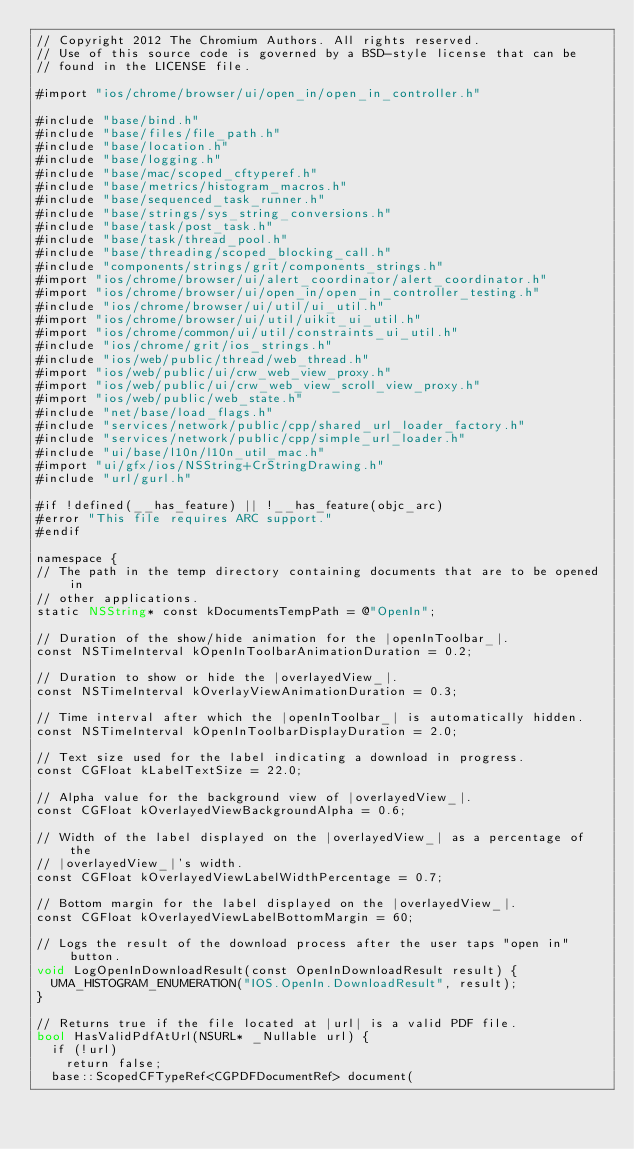Convert code to text. <code><loc_0><loc_0><loc_500><loc_500><_ObjectiveC_>// Copyright 2012 The Chromium Authors. All rights reserved.
// Use of this source code is governed by a BSD-style license that can be
// found in the LICENSE file.

#import "ios/chrome/browser/ui/open_in/open_in_controller.h"

#include "base/bind.h"
#include "base/files/file_path.h"
#include "base/location.h"
#include "base/logging.h"
#include "base/mac/scoped_cftyperef.h"
#include "base/metrics/histogram_macros.h"
#include "base/sequenced_task_runner.h"
#include "base/strings/sys_string_conversions.h"
#include "base/task/post_task.h"
#include "base/task/thread_pool.h"
#include "base/threading/scoped_blocking_call.h"
#include "components/strings/grit/components_strings.h"
#import "ios/chrome/browser/ui/alert_coordinator/alert_coordinator.h"
#import "ios/chrome/browser/ui/open_in/open_in_controller_testing.h"
#include "ios/chrome/browser/ui/util/ui_util.h"
#import "ios/chrome/browser/ui/util/uikit_ui_util.h"
#import "ios/chrome/common/ui/util/constraints_ui_util.h"
#include "ios/chrome/grit/ios_strings.h"
#include "ios/web/public/thread/web_thread.h"
#import "ios/web/public/ui/crw_web_view_proxy.h"
#import "ios/web/public/ui/crw_web_view_scroll_view_proxy.h"
#import "ios/web/public/web_state.h"
#include "net/base/load_flags.h"
#include "services/network/public/cpp/shared_url_loader_factory.h"
#include "services/network/public/cpp/simple_url_loader.h"
#include "ui/base/l10n/l10n_util_mac.h"
#import "ui/gfx/ios/NSString+CrStringDrawing.h"
#include "url/gurl.h"

#if !defined(__has_feature) || !__has_feature(objc_arc)
#error "This file requires ARC support."
#endif

namespace {
// The path in the temp directory containing documents that are to be opened in
// other applications.
static NSString* const kDocumentsTempPath = @"OpenIn";

// Duration of the show/hide animation for the |openInToolbar_|.
const NSTimeInterval kOpenInToolbarAnimationDuration = 0.2;

// Duration to show or hide the |overlayedView_|.
const NSTimeInterval kOverlayViewAnimationDuration = 0.3;

// Time interval after which the |openInToolbar_| is automatically hidden.
const NSTimeInterval kOpenInToolbarDisplayDuration = 2.0;

// Text size used for the label indicating a download in progress.
const CGFloat kLabelTextSize = 22.0;

// Alpha value for the background view of |overlayedView_|.
const CGFloat kOverlayedViewBackgroundAlpha = 0.6;

// Width of the label displayed on the |overlayedView_| as a percentage of the
// |overlayedView_|'s width.
const CGFloat kOverlayedViewLabelWidthPercentage = 0.7;

// Bottom margin for the label displayed on the |overlayedView_|.
const CGFloat kOverlayedViewLabelBottomMargin = 60;

// Logs the result of the download process after the user taps "open in" button.
void LogOpenInDownloadResult(const OpenInDownloadResult result) {
  UMA_HISTOGRAM_ENUMERATION("IOS.OpenIn.DownloadResult", result);
}

// Returns true if the file located at |url| is a valid PDF file.
bool HasValidPdfAtUrl(NSURL* _Nullable url) {
  if (!url)
    return false;
  base::ScopedCFTypeRef<CGPDFDocumentRef> document(</code> 